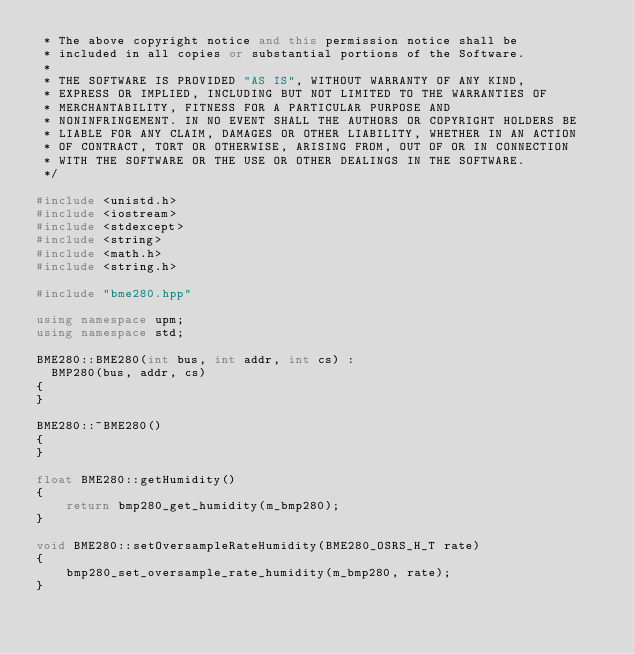Convert code to text. <code><loc_0><loc_0><loc_500><loc_500><_C++_> * The above copyright notice and this permission notice shall be
 * included in all copies or substantial portions of the Software.
 *
 * THE SOFTWARE IS PROVIDED "AS IS", WITHOUT WARRANTY OF ANY KIND,
 * EXPRESS OR IMPLIED, INCLUDING BUT NOT LIMITED TO THE WARRANTIES OF
 * MERCHANTABILITY, FITNESS FOR A PARTICULAR PURPOSE AND
 * NONINFRINGEMENT. IN NO EVENT SHALL THE AUTHORS OR COPYRIGHT HOLDERS BE
 * LIABLE FOR ANY CLAIM, DAMAGES OR OTHER LIABILITY, WHETHER IN AN ACTION
 * OF CONTRACT, TORT OR OTHERWISE, ARISING FROM, OUT OF OR IN CONNECTION
 * WITH THE SOFTWARE OR THE USE OR OTHER DEALINGS IN THE SOFTWARE.
 */

#include <unistd.h>
#include <iostream>
#include <stdexcept>
#include <string>
#include <math.h>
#include <string.h>

#include "bme280.hpp"

using namespace upm;
using namespace std;

BME280::BME280(int bus, int addr, int cs) :
  BMP280(bus, addr, cs)
{
}

BME280::~BME280()
{
}

float BME280::getHumidity()
{
    return bmp280_get_humidity(m_bmp280);
}

void BME280::setOversampleRateHumidity(BME280_OSRS_H_T rate)
{
    bmp280_set_oversample_rate_humidity(m_bmp280, rate);
}
</code> 